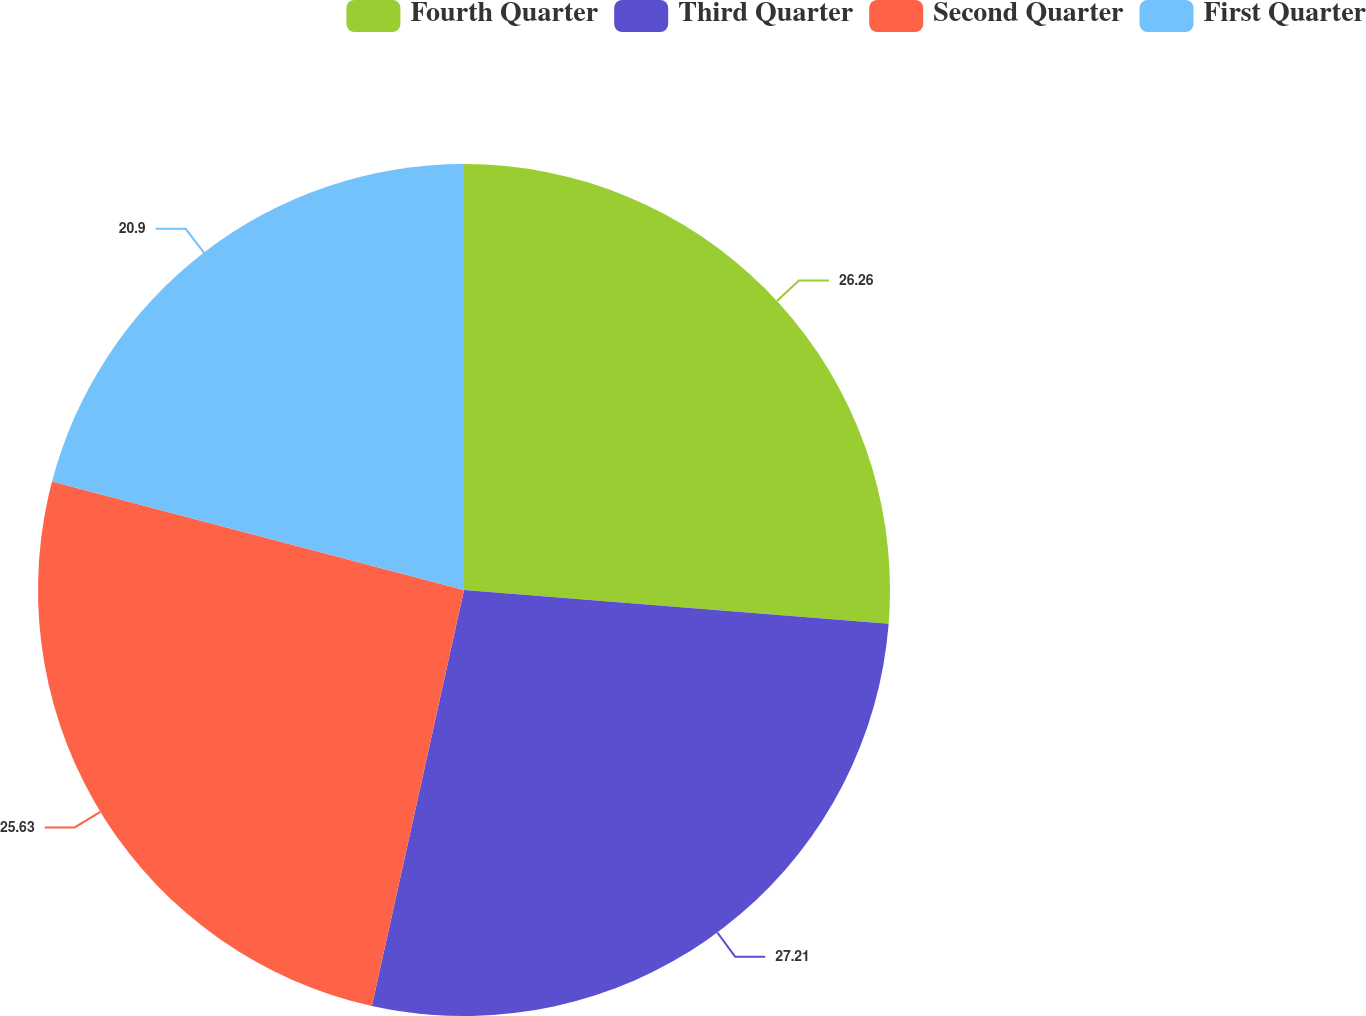Convert chart to OTSL. <chart><loc_0><loc_0><loc_500><loc_500><pie_chart><fcel>Fourth Quarter<fcel>Third Quarter<fcel>Second Quarter<fcel>First Quarter<nl><fcel>26.26%<fcel>27.21%<fcel>25.63%<fcel>20.9%<nl></chart> 